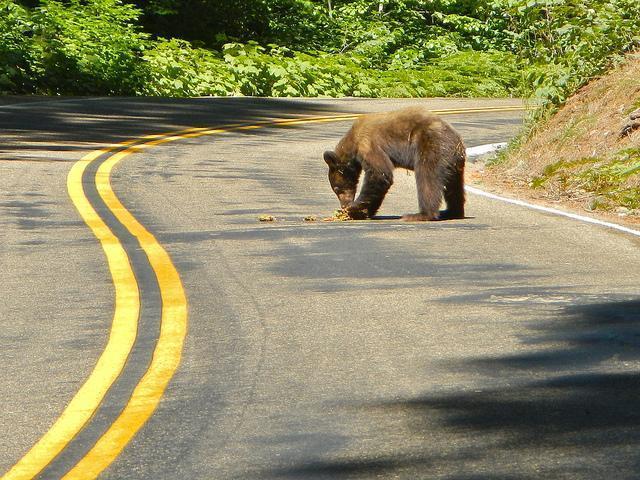How many elephants have 2 people riding them?
Give a very brief answer. 0. 